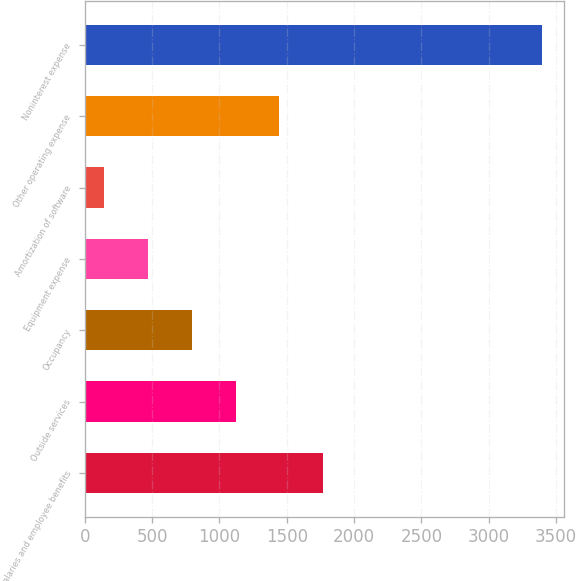Convert chart to OTSL. <chart><loc_0><loc_0><loc_500><loc_500><bar_chart><fcel>Salaries and employee benefits<fcel>Outside services<fcel>Occupancy<fcel>Equipment expense<fcel>Amortization of software<fcel>Other operating expense<fcel>Noninterest expense<nl><fcel>1768.5<fcel>1119.1<fcel>794.4<fcel>469.7<fcel>145<fcel>1443.8<fcel>3392<nl></chart> 